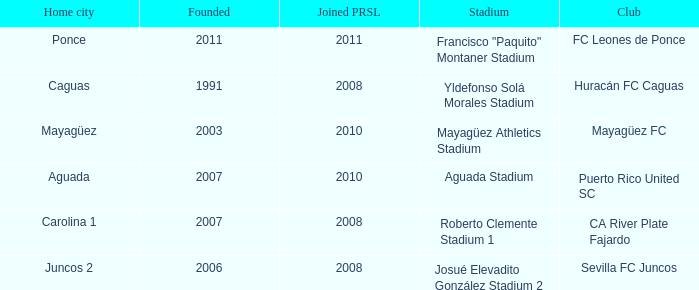What is the club that was founded before 2007, joined prsl in 2008 and the stadium is yldefonso solá morales stadium? Huracán FC Caguas. 